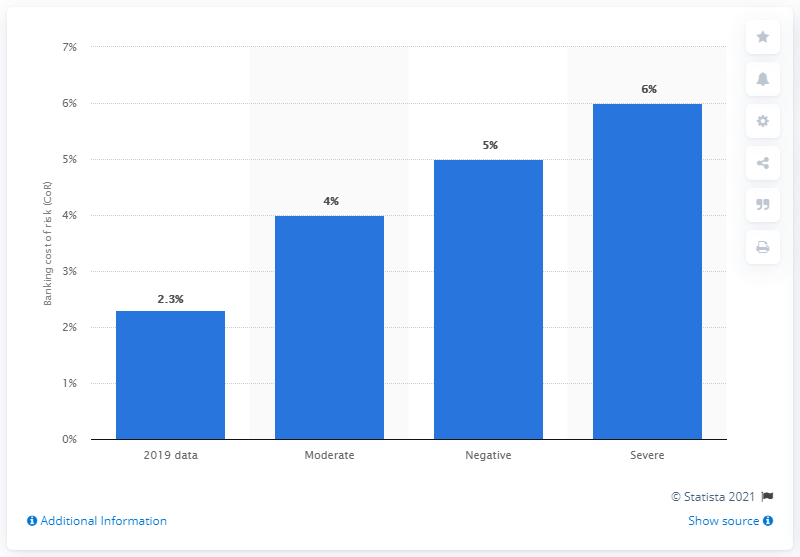Give some essential details in this illustration. In 2019, the capital adequacy ratio (CoR) of the Russian banking sector was set at 2.3%. 